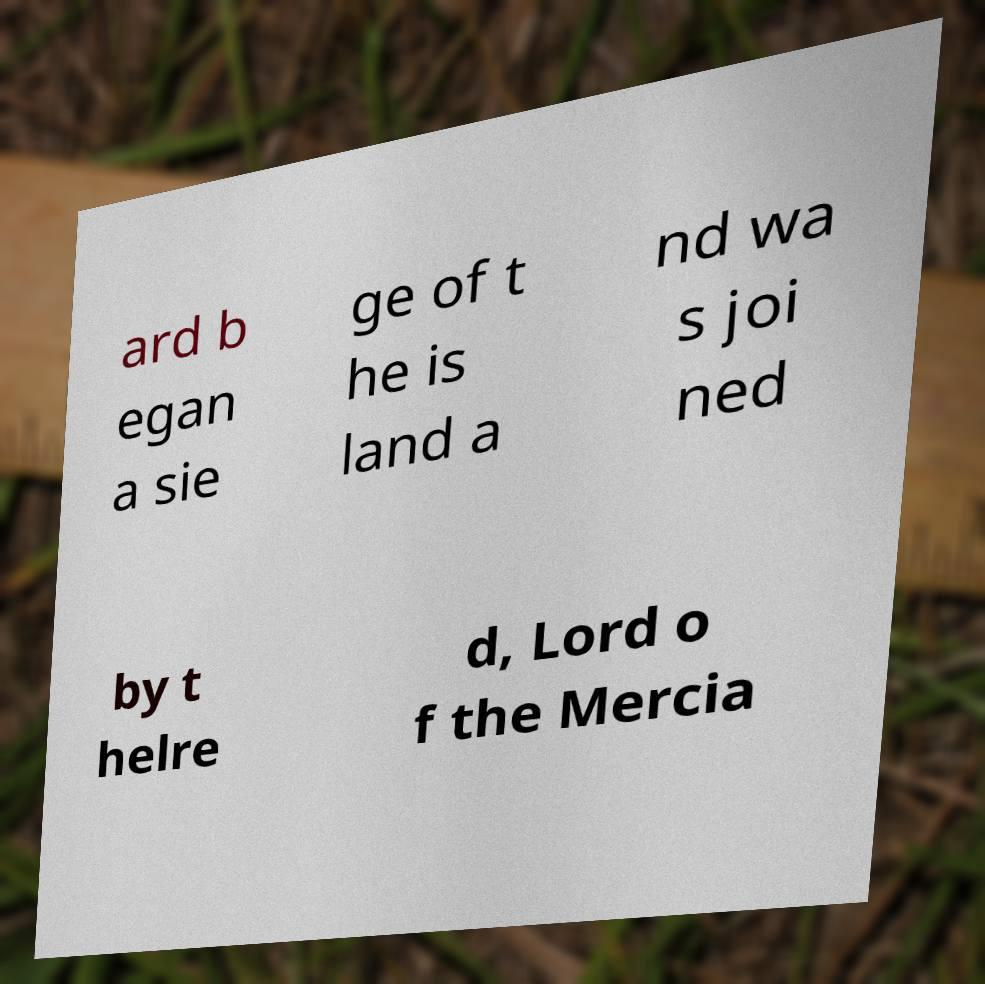What messages or text are displayed in this image? I need them in a readable, typed format. ard b egan a sie ge of t he is land a nd wa s joi ned by t helre d, Lord o f the Mercia 